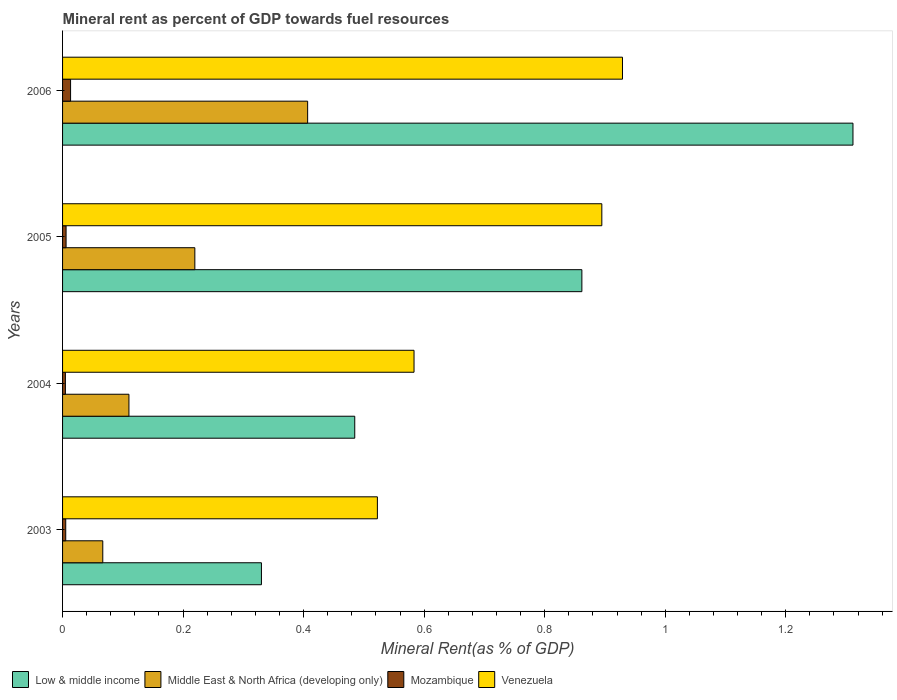How many different coloured bars are there?
Offer a very short reply. 4. How many groups of bars are there?
Provide a short and direct response. 4. Are the number of bars on each tick of the Y-axis equal?
Provide a succinct answer. Yes. How many bars are there on the 3rd tick from the top?
Offer a very short reply. 4. How many bars are there on the 4th tick from the bottom?
Your answer should be compact. 4. What is the mineral rent in Middle East & North Africa (developing only) in 2006?
Give a very brief answer. 0.41. Across all years, what is the maximum mineral rent in Middle East & North Africa (developing only)?
Provide a succinct answer. 0.41. Across all years, what is the minimum mineral rent in Low & middle income?
Provide a succinct answer. 0.33. In which year was the mineral rent in Low & middle income maximum?
Provide a succinct answer. 2006. In which year was the mineral rent in Low & middle income minimum?
Your answer should be very brief. 2003. What is the total mineral rent in Mozambique in the graph?
Give a very brief answer. 0.03. What is the difference between the mineral rent in Low & middle income in 2004 and that in 2005?
Your answer should be very brief. -0.38. What is the difference between the mineral rent in Mozambique in 2006 and the mineral rent in Middle East & North Africa (developing only) in 2003?
Ensure brevity in your answer.  -0.05. What is the average mineral rent in Mozambique per year?
Your answer should be very brief. 0.01. In the year 2003, what is the difference between the mineral rent in Middle East & North Africa (developing only) and mineral rent in Mozambique?
Provide a succinct answer. 0.06. What is the ratio of the mineral rent in Middle East & North Africa (developing only) in 2004 to that in 2006?
Make the answer very short. 0.27. What is the difference between the highest and the second highest mineral rent in Middle East & North Africa (developing only)?
Offer a terse response. 0.19. What is the difference between the highest and the lowest mineral rent in Mozambique?
Your answer should be very brief. 0.01. Is the sum of the mineral rent in Venezuela in 2003 and 2004 greater than the maximum mineral rent in Mozambique across all years?
Provide a succinct answer. Yes. What does the 1st bar from the top in 2003 represents?
Offer a terse response. Venezuela. What does the 4th bar from the bottom in 2006 represents?
Offer a very short reply. Venezuela. Are the values on the major ticks of X-axis written in scientific E-notation?
Your answer should be compact. No. Does the graph contain grids?
Offer a terse response. No. Where does the legend appear in the graph?
Offer a very short reply. Bottom left. How many legend labels are there?
Give a very brief answer. 4. How are the legend labels stacked?
Offer a very short reply. Horizontal. What is the title of the graph?
Make the answer very short. Mineral rent as percent of GDP towards fuel resources. Does "Australia" appear as one of the legend labels in the graph?
Ensure brevity in your answer.  No. What is the label or title of the X-axis?
Your response must be concise. Mineral Rent(as % of GDP). What is the label or title of the Y-axis?
Provide a succinct answer. Years. What is the Mineral Rent(as % of GDP) of Low & middle income in 2003?
Offer a very short reply. 0.33. What is the Mineral Rent(as % of GDP) in Middle East & North Africa (developing only) in 2003?
Offer a terse response. 0.07. What is the Mineral Rent(as % of GDP) in Mozambique in 2003?
Offer a very short reply. 0.01. What is the Mineral Rent(as % of GDP) of Venezuela in 2003?
Your answer should be compact. 0.52. What is the Mineral Rent(as % of GDP) in Low & middle income in 2004?
Provide a short and direct response. 0.48. What is the Mineral Rent(as % of GDP) in Middle East & North Africa (developing only) in 2004?
Offer a terse response. 0.11. What is the Mineral Rent(as % of GDP) of Mozambique in 2004?
Offer a very short reply. 0. What is the Mineral Rent(as % of GDP) of Venezuela in 2004?
Make the answer very short. 0.58. What is the Mineral Rent(as % of GDP) in Low & middle income in 2005?
Give a very brief answer. 0.86. What is the Mineral Rent(as % of GDP) of Middle East & North Africa (developing only) in 2005?
Your answer should be compact. 0.22. What is the Mineral Rent(as % of GDP) of Mozambique in 2005?
Keep it short and to the point. 0.01. What is the Mineral Rent(as % of GDP) in Venezuela in 2005?
Provide a short and direct response. 0.89. What is the Mineral Rent(as % of GDP) in Low & middle income in 2006?
Provide a short and direct response. 1.31. What is the Mineral Rent(as % of GDP) in Middle East & North Africa (developing only) in 2006?
Keep it short and to the point. 0.41. What is the Mineral Rent(as % of GDP) of Mozambique in 2006?
Provide a short and direct response. 0.01. What is the Mineral Rent(as % of GDP) in Venezuela in 2006?
Offer a terse response. 0.93. Across all years, what is the maximum Mineral Rent(as % of GDP) in Low & middle income?
Provide a succinct answer. 1.31. Across all years, what is the maximum Mineral Rent(as % of GDP) in Middle East & North Africa (developing only)?
Keep it short and to the point. 0.41. Across all years, what is the maximum Mineral Rent(as % of GDP) in Mozambique?
Give a very brief answer. 0.01. Across all years, what is the maximum Mineral Rent(as % of GDP) of Venezuela?
Ensure brevity in your answer.  0.93. Across all years, what is the minimum Mineral Rent(as % of GDP) of Low & middle income?
Your answer should be compact. 0.33. Across all years, what is the minimum Mineral Rent(as % of GDP) in Middle East & North Africa (developing only)?
Offer a very short reply. 0.07. Across all years, what is the minimum Mineral Rent(as % of GDP) in Mozambique?
Your response must be concise. 0. Across all years, what is the minimum Mineral Rent(as % of GDP) of Venezuela?
Make the answer very short. 0.52. What is the total Mineral Rent(as % of GDP) in Low & middle income in the graph?
Give a very brief answer. 2.99. What is the total Mineral Rent(as % of GDP) of Middle East & North Africa (developing only) in the graph?
Offer a terse response. 0.8. What is the total Mineral Rent(as % of GDP) in Mozambique in the graph?
Provide a succinct answer. 0.03. What is the total Mineral Rent(as % of GDP) in Venezuela in the graph?
Ensure brevity in your answer.  2.93. What is the difference between the Mineral Rent(as % of GDP) of Low & middle income in 2003 and that in 2004?
Your answer should be very brief. -0.15. What is the difference between the Mineral Rent(as % of GDP) of Middle East & North Africa (developing only) in 2003 and that in 2004?
Offer a terse response. -0.04. What is the difference between the Mineral Rent(as % of GDP) in Mozambique in 2003 and that in 2004?
Provide a short and direct response. 0. What is the difference between the Mineral Rent(as % of GDP) of Venezuela in 2003 and that in 2004?
Ensure brevity in your answer.  -0.06. What is the difference between the Mineral Rent(as % of GDP) in Low & middle income in 2003 and that in 2005?
Keep it short and to the point. -0.53. What is the difference between the Mineral Rent(as % of GDP) in Middle East & North Africa (developing only) in 2003 and that in 2005?
Keep it short and to the point. -0.15. What is the difference between the Mineral Rent(as % of GDP) in Mozambique in 2003 and that in 2005?
Provide a short and direct response. -0. What is the difference between the Mineral Rent(as % of GDP) in Venezuela in 2003 and that in 2005?
Keep it short and to the point. -0.37. What is the difference between the Mineral Rent(as % of GDP) of Low & middle income in 2003 and that in 2006?
Provide a short and direct response. -0.98. What is the difference between the Mineral Rent(as % of GDP) in Middle East & North Africa (developing only) in 2003 and that in 2006?
Provide a succinct answer. -0.34. What is the difference between the Mineral Rent(as % of GDP) in Mozambique in 2003 and that in 2006?
Your answer should be compact. -0.01. What is the difference between the Mineral Rent(as % of GDP) in Venezuela in 2003 and that in 2006?
Offer a very short reply. -0.41. What is the difference between the Mineral Rent(as % of GDP) of Low & middle income in 2004 and that in 2005?
Give a very brief answer. -0.38. What is the difference between the Mineral Rent(as % of GDP) of Middle East & North Africa (developing only) in 2004 and that in 2005?
Offer a terse response. -0.11. What is the difference between the Mineral Rent(as % of GDP) of Mozambique in 2004 and that in 2005?
Your answer should be compact. -0. What is the difference between the Mineral Rent(as % of GDP) of Venezuela in 2004 and that in 2005?
Give a very brief answer. -0.31. What is the difference between the Mineral Rent(as % of GDP) of Low & middle income in 2004 and that in 2006?
Provide a succinct answer. -0.83. What is the difference between the Mineral Rent(as % of GDP) of Middle East & North Africa (developing only) in 2004 and that in 2006?
Make the answer very short. -0.3. What is the difference between the Mineral Rent(as % of GDP) in Mozambique in 2004 and that in 2006?
Keep it short and to the point. -0.01. What is the difference between the Mineral Rent(as % of GDP) of Venezuela in 2004 and that in 2006?
Offer a terse response. -0.35. What is the difference between the Mineral Rent(as % of GDP) in Low & middle income in 2005 and that in 2006?
Make the answer very short. -0.45. What is the difference between the Mineral Rent(as % of GDP) in Middle East & North Africa (developing only) in 2005 and that in 2006?
Provide a short and direct response. -0.19. What is the difference between the Mineral Rent(as % of GDP) of Mozambique in 2005 and that in 2006?
Ensure brevity in your answer.  -0.01. What is the difference between the Mineral Rent(as % of GDP) of Venezuela in 2005 and that in 2006?
Make the answer very short. -0.03. What is the difference between the Mineral Rent(as % of GDP) of Low & middle income in 2003 and the Mineral Rent(as % of GDP) of Middle East & North Africa (developing only) in 2004?
Keep it short and to the point. 0.22. What is the difference between the Mineral Rent(as % of GDP) of Low & middle income in 2003 and the Mineral Rent(as % of GDP) of Mozambique in 2004?
Your answer should be very brief. 0.33. What is the difference between the Mineral Rent(as % of GDP) of Low & middle income in 2003 and the Mineral Rent(as % of GDP) of Venezuela in 2004?
Offer a very short reply. -0.25. What is the difference between the Mineral Rent(as % of GDP) of Middle East & North Africa (developing only) in 2003 and the Mineral Rent(as % of GDP) of Mozambique in 2004?
Ensure brevity in your answer.  0.06. What is the difference between the Mineral Rent(as % of GDP) in Middle East & North Africa (developing only) in 2003 and the Mineral Rent(as % of GDP) in Venezuela in 2004?
Offer a terse response. -0.52. What is the difference between the Mineral Rent(as % of GDP) in Mozambique in 2003 and the Mineral Rent(as % of GDP) in Venezuela in 2004?
Ensure brevity in your answer.  -0.58. What is the difference between the Mineral Rent(as % of GDP) of Low & middle income in 2003 and the Mineral Rent(as % of GDP) of Middle East & North Africa (developing only) in 2005?
Make the answer very short. 0.11. What is the difference between the Mineral Rent(as % of GDP) of Low & middle income in 2003 and the Mineral Rent(as % of GDP) of Mozambique in 2005?
Offer a terse response. 0.32. What is the difference between the Mineral Rent(as % of GDP) of Low & middle income in 2003 and the Mineral Rent(as % of GDP) of Venezuela in 2005?
Your answer should be very brief. -0.56. What is the difference between the Mineral Rent(as % of GDP) of Middle East & North Africa (developing only) in 2003 and the Mineral Rent(as % of GDP) of Mozambique in 2005?
Provide a succinct answer. 0.06. What is the difference between the Mineral Rent(as % of GDP) in Middle East & North Africa (developing only) in 2003 and the Mineral Rent(as % of GDP) in Venezuela in 2005?
Your answer should be compact. -0.83. What is the difference between the Mineral Rent(as % of GDP) of Mozambique in 2003 and the Mineral Rent(as % of GDP) of Venezuela in 2005?
Provide a short and direct response. -0.89. What is the difference between the Mineral Rent(as % of GDP) in Low & middle income in 2003 and the Mineral Rent(as % of GDP) in Middle East & North Africa (developing only) in 2006?
Keep it short and to the point. -0.08. What is the difference between the Mineral Rent(as % of GDP) in Low & middle income in 2003 and the Mineral Rent(as % of GDP) in Mozambique in 2006?
Provide a succinct answer. 0.32. What is the difference between the Mineral Rent(as % of GDP) in Low & middle income in 2003 and the Mineral Rent(as % of GDP) in Venezuela in 2006?
Make the answer very short. -0.6. What is the difference between the Mineral Rent(as % of GDP) of Middle East & North Africa (developing only) in 2003 and the Mineral Rent(as % of GDP) of Mozambique in 2006?
Give a very brief answer. 0.05. What is the difference between the Mineral Rent(as % of GDP) in Middle East & North Africa (developing only) in 2003 and the Mineral Rent(as % of GDP) in Venezuela in 2006?
Offer a terse response. -0.86. What is the difference between the Mineral Rent(as % of GDP) in Mozambique in 2003 and the Mineral Rent(as % of GDP) in Venezuela in 2006?
Offer a terse response. -0.92. What is the difference between the Mineral Rent(as % of GDP) of Low & middle income in 2004 and the Mineral Rent(as % of GDP) of Middle East & North Africa (developing only) in 2005?
Ensure brevity in your answer.  0.27. What is the difference between the Mineral Rent(as % of GDP) in Low & middle income in 2004 and the Mineral Rent(as % of GDP) in Mozambique in 2005?
Provide a short and direct response. 0.48. What is the difference between the Mineral Rent(as % of GDP) in Low & middle income in 2004 and the Mineral Rent(as % of GDP) in Venezuela in 2005?
Your response must be concise. -0.41. What is the difference between the Mineral Rent(as % of GDP) of Middle East & North Africa (developing only) in 2004 and the Mineral Rent(as % of GDP) of Mozambique in 2005?
Give a very brief answer. 0.1. What is the difference between the Mineral Rent(as % of GDP) of Middle East & North Africa (developing only) in 2004 and the Mineral Rent(as % of GDP) of Venezuela in 2005?
Give a very brief answer. -0.78. What is the difference between the Mineral Rent(as % of GDP) in Mozambique in 2004 and the Mineral Rent(as % of GDP) in Venezuela in 2005?
Your response must be concise. -0.89. What is the difference between the Mineral Rent(as % of GDP) in Low & middle income in 2004 and the Mineral Rent(as % of GDP) in Middle East & North Africa (developing only) in 2006?
Make the answer very short. 0.08. What is the difference between the Mineral Rent(as % of GDP) of Low & middle income in 2004 and the Mineral Rent(as % of GDP) of Mozambique in 2006?
Ensure brevity in your answer.  0.47. What is the difference between the Mineral Rent(as % of GDP) in Low & middle income in 2004 and the Mineral Rent(as % of GDP) in Venezuela in 2006?
Your response must be concise. -0.44. What is the difference between the Mineral Rent(as % of GDP) in Middle East & North Africa (developing only) in 2004 and the Mineral Rent(as % of GDP) in Mozambique in 2006?
Make the answer very short. 0.1. What is the difference between the Mineral Rent(as % of GDP) of Middle East & North Africa (developing only) in 2004 and the Mineral Rent(as % of GDP) of Venezuela in 2006?
Make the answer very short. -0.82. What is the difference between the Mineral Rent(as % of GDP) of Mozambique in 2004 and the Mineral Rent(as % of GDP) of Venezuela in 2006?
Provide a succinct answer. -0.92. What is the difference between the Mineral Rent(as % of GDP) of Low & middle income in 2005 and the Mineral Rent(as % of GDP) of Middle East & North Africa (developing only) in 2006?
Provide a succinct answer. 0.46. What is the difference between the Mineral Rent(as % of GDP) in Low & middle income in 2005 and the Mineral Rent(as % of GDP) in Mozambique in 2006?
Keep it short and to the point. 0.85. What is the difference between the Mineral Rent(as % of GDP) of Low & middle income in 2005 and the Mineral Rent(as % of GDP) of Venezuela in 2006?
Ensure brevity in your answer.  -0.07. What is the difference between the Mineral Rent(as % of GDP) of Middle East & North Africa (developing only) in 2005 and the Mineral Rent(as % of GDP) of Mozambique in 2006?
Ensure brevity in your answer.  0.21. What is the difference between the Mineral Rent(as % of GDP) of Middle East & North Africa (developing only) in 2005 and the Mineral Rent(as % of GDP) of Venezuela in 2006?
Ensure brevity in your answer.  -0.71. What is the difference between the Mineral Rent(as % of GDP) of Mozambique in 2005 and the Mineral Rent(as % of GDP) of Venezuela in 2006?
Give a very brief answer. -0.92. What is the average Mineral Rent(as % of GDP) of Low & middle income per year?
Your answer should be very brief. 0.75. What is the average Mineral Rent(as % of GDP) of Middle East & North Africa (developing only) per year?
Provide a short and direct response. 0.2. What is the average Mineral Rent(as % of GDP) of Mozambique per year?
Provide a succinct answer. 0.01. What is the average Mineral Rent(as % of GDP) in Venezuela per year?
Offer a very short reply. 0.73. In the year 2003, what is the difference between the Mineral Rent(as % of GDP) in Low & middle income and Mineral Rent(as % of GDP) in Middle East & North Africa (developing only)?
Your answer should be very brief. 0.26. In the year 2003, what is the difference between the Mineral Rent(as % of GDP) of Low & middle income and Mineral Rent(as % of GDP) of Mozambique?
Keep it short and to the point. 0.32. In the year 2003, what is the difference between the Mineral Rent(as % of GDP) of Low & middle income and Mineral Rent(as % of GDP) of Venezuela?
Keep it short and to the point. -0.19. In the year 2003, what is the difference between the Mineral Rent(as % of GDP) of Middle East & North Africa (developing only) and Mineral Rent(as % of GDP) of Mozambique?
Offer a terse response. 0.06. In the year 2003, what is the difference between the Mineral Rent(as % of GDP) in Middle East & North Africa (developing only) and Mineral Rent(as % of GDP) in Venezuela?
Offer a very short reply. -0.46. In the year 2003, what is the difference between the Mineral Rent(as % of GDP) of Mozambique and Mineral Rent(as % of GDP) of Venezuela?
Your response must be concise. -0.52. In the year 2004, what is the difference between the Mineral Rent(as % of GDP) of Low & middle income and Mineral Rent(as % of GDP) of Middle East & North Africa (developing only)?
Your response must be concise. 0.37. In the year 2004, what is the difference between the Mineral Rent(as % of GDP) in Low & middle income and Mineral Rent(as % of GDP) in Mozambique?
Your answer should be compact. 0.48. In the year 2004, what is the difference between the Mineral Rent(as % of GDP) in Low & middle income and Mineral Rent(as % of GDP) in Venezuela?
Offer a very short reply. -0.1. In the year 2004, what is the difference between the Mineral Rent(as % of GDP) of Middle East & North Africa (developing only) and Mineral Rent(as % of GDP) of Mozambique?
Ensure brevity in your answer.  0.11. In the year 2004, what is the difference between the Mineral Rent(as % of GDP) in Middle East & North Africa (developing only) and Mineral Rent(as % of GDP) in Venezuela?
Provide a short and direct response. -0.47. In the year 2004, what is the difference between the Mineral Rent(as % of GDP) of Mozambique and Mineral Rent(as % of GDP) of Venezuela?
Your answer should be very brief. -0.58. In the year 2005, what is the difference between the Mineral Rent(as % of GDP) in Low & middle income and Mineral Rent(as % of GDP) in Middle East & North Africa (developing only)?
Your response must be concise. 0.64. In the year 2005, what is the difference between the Mineral Rent(as % of GDP) of Low & middle income and Mineral Rent(as % of GDP) of Mozambique?
Keep it short and to the point. 0.86. In the year 2005, what is the difference between the Mineral Rent(as % of GDP) of Low & middle income and Mineral Rent(as % of GDP) of Venezuela?
Give a very brief answer. -0.03. In the year 2005, what is the difference between the Mineral Rent(as % of GDP) of Middle East & North Africa (developing only) and Mineral Rent(as % of GDP) of Mozambique?
Ensure brevity in your answer.  0.21. In the year 2005, what is the difference between the Mineral Rent(as % of GDP) of Middle East & North Africa (developing only) and Mineral Rent(as % of GDP) of Venezuela?
Your response must be concise. -0.68. In the year 2005, what is the difference between the Mineral Rent(as % of GDP) of Mozambique and Mineral Rent(as % of GDP) of Venezuela?
Your answer should be compact. -0.89. In the year 2006, what is the difference between the Mineral Rent(as % of GDP) of Low & middle income and Mineral Rent(as % of GDP) of Middle East & North Africa (developing only)?
Your response must be concise. 0.9. In the year 2006, what is the difference between the Mineral Rent(as % of GDP) of Low & middle income and Mineral Rent(as % of GDP) of Mozambique?
Make the answer very short. 1.3. In the year 2006, what is the difference between the Mineral Rent(as % of GDP) of Low & middle income and Mineral Rent(as % of GDP) of Venezuela?
Provide a short and direct response. 0.38. In the year 2006, what is the difference between the Mineral Rent(as % of GDP) of Middle East & North Africa (developing only) and Mineral Rent(as % of GDP) of Mozambique?
Provide a short and direct response. 0.39. In the year 2006, what is the difference between the Mineral Rent(as % of GDP) in Middle East & North Africa (developing only) and Mineral Rent(as % of GDP) in Venezuela?
Your response must be concise. -0.52. In the year 2006, what is the difference between the Mineral Rent(as % of GDP) in Mozambique and Mineral Rent(as % of GDP) in Venezuela?
Make the answer very short. -0.92. What is the ratio of the Mineral Rent(as % of GDP) of Low & middle income in 2003 to that in 2004?
Give a very brief answer. 0.68. What is the ratio of the Mineral Rent(as % of GDP) of Middle East & North Africa (developing only) in 2003 to that in 2004?
Your answer should be compact. 0.61. What is the ratio of the Mineral Rent(as % of GDP) in Mozambique in 2003 to that in 2004?
Give a very brief answer. 1.12. What is the ratio of the Mineral Rent(as % of GDP) in Venezuela in 2003 to that in 2004?
Keep it short and to the point. 0.9. What is the ratio of the Mineral Rent(as % of GDP) in Low & middle income in 2003 to that in 2005?
Keep it short and to the point. 0.38. What is the ratio of the Mineral Rent(as % of GDP) in Middle East & North Africa (developing only) in 2003 to that in 2005?
Provide a succinct answer. 0.3. What is the ratio of the Mineral Rent(as % of GDP) in Mozambique in 2003 to that in 2005?
Provide a succinct answer. 0.9. What is the ratio of the Mineral Rent(as % of GDP) of Venezuela in 2003 to that in 2005?
Offer a terse response. 0.58. What is the ratio of the Mineral Rent(as % of GDP) in Low & middle income in 2003 to that in 2006?
Your answer should be very brief. 0.25. What is the ratio of the Mineral Rent(as % of GDP) of Middle East & North Africa (developing only) in 2003 to that in 2006?
Provide a short and direct response. 0.16. What is the ratio of the Mineral Rent(as % of GDP) of Mozambique in 2003 to that in 2006?
Your answer should be very brief. 0.4. What is the ratio of the Mineral Rent(as % of GDP) of Venezuela in 2003 to that in 2006?
Give a very brief answer. 0.56. What is the ratio of the Mineral Rent(as % of GDP) of Low & middle income in 2004 to that in 2005?
Your answer should be compact. 0.56. What is the ratio of the Mineral Rent(as % of GDP) of Middle East & North Africa (developing only) in 2004 to that in 2005?
Provide a succinct answer. 0.5. What is the ratio of the Mineral Rent(as % of GDP) in Mozambique in 2004 to that in 2005?
Give a very brief answer. 0.81. What is the ratio of the Mineral Rent(as % of GDP) in Venezuela in 2004 to that in 2005?
Ensure brevity in your answer.  0.65. What is the ratio of the Mineral Rent(as % of GDP) of Low & middle income in 2004 to that in 2006?
Make the answer very short. 0.37. What is the ratio of the Mineral Rent(as % of GDP) of Middle East & North Africa (developing only) in 2004 to that in 2006?
Keep it short and to the point. 0.27. What is the ratio of the Mineral Rent(as % of GDP) of Mozambique in 2004 to that in 2006?
Offer a very short reply. 0.35. What is the ratio of the Mineral Rent(as % of GDP) of Venezuela in 2004 to that in 2006?
Ensure brevity in your answer.  0.63. What is the ratio of the Mineral Rent(as % of GDP) of Low & middle income in 2005 to that in 2006?
Your answer should be compact. 0.66. What is the ratio of the Mineral Rent(as % of GDP) of Middle East & North Africa (developing only) in 2005 to that in 2006?
Your answer should be very brief. 0.54. What is the ratio of the Mineral Rent(as % of GDP) of Mozambique in 2005 to that in 2006?
Offer a terse response. 0.44. What is the ratio of the Mineral Rent(as % of GDP) of Venezuela in 2005 to that in 2006?
Make the answer very short. 0.96. What is the difference between the highest and the second highest Mineral Rent(as % of GDP) in Low & middle income?
Make the answer very short. 0.45. What is the difference between the highest and the second highest Mineral Rent(as % of GDP) of Middle East & North Africa (developing only)?
Your answer should be very brief. 0.19. What is the difference between the highest and the second highest Mineral Rent(as % of GDP) of Mozambique?
Offer a terse response. 0.01. What is the difference between the highest and the second highest Mineral Rent(as % of GDP) in Venezuela?
Make the answer very short. 0.03. What is the difference between the highest and the lowest Mineral Rent(as % of GDP) of Low & middle income?
Your answer should be compact. 0.98. What is the difference between the highest and the lowest Mineral Rent(as % of GDP) of Middle East & North Africa (developing only)?
Your answer should be compact. 0.34. What is the difference between the highest and the lowest Mineral Rent(as % of GDP) in Mozambique?
Ensure brevity in your answer.  0.01. What is the difference between the highest and the lowest Mineral Rent(as % of GDP) of Venezuela?
Ensure brevity in your answer.  0.41. 